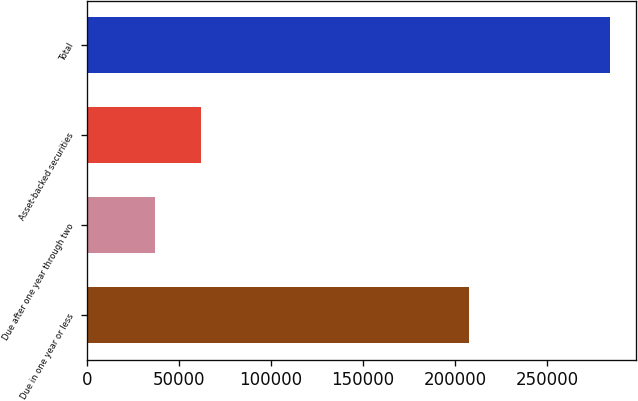Convert chart to OTSL. <chart><loc_0><loc_0><loc_500><loc_500><bar_chart><fcel>Due in one year or less<fcel>Due after one year through two<fcel>Asset-backed securities<fcel>Total<nl><fcel>207762<fcel>37066<fcel>61769.3<fcel>284099<nl></chart> 